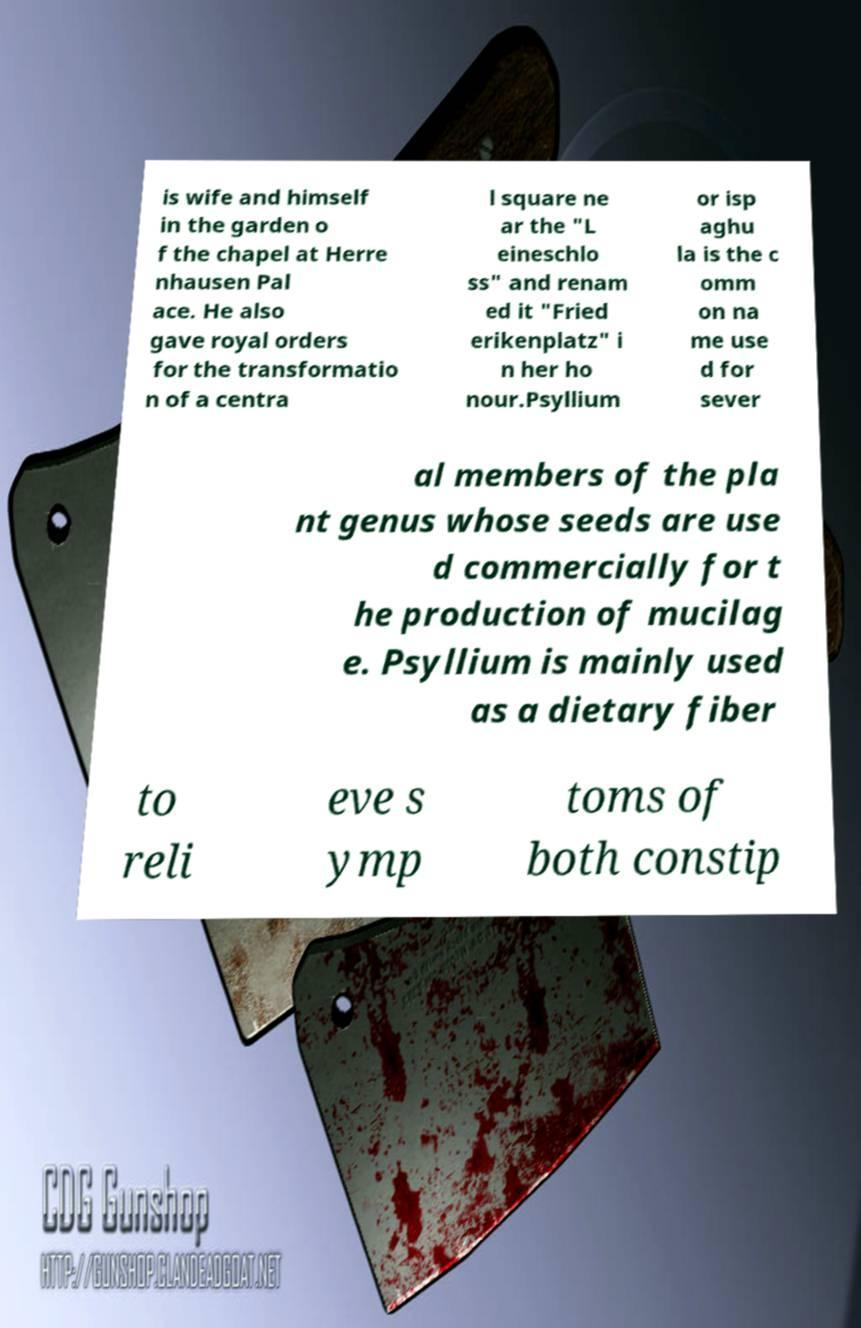I need the written content from this picture converted into text. Can you do that? is wife and himself in the garden o f the chapel at Herre nhausen Pal ace. He also gave royal orders for the transformatio n of a centra l square ne ar the "L eineschlo ss" and renam ed it "Fried erikenplatz" i n her ho nour.Psyllium or isp aghu la is the c omm on na me use d for sever al members of the pla nt genus whose seeds are use d commercially for t he production of mucilag e. Psyllium is mainly used as a dietary fiber to reli eve s ymp toms of both constip 